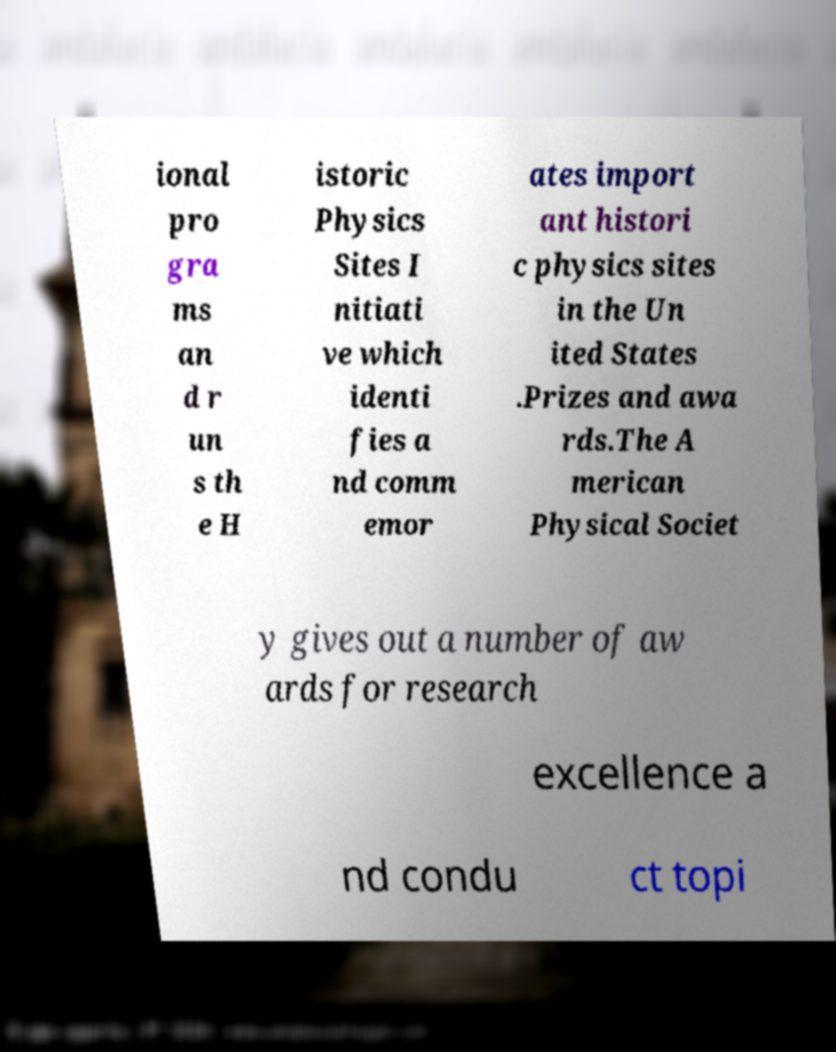Could you extract and type out the text from this image? ional pro gra ms an d r un s th e H istoric Physics Sites I nitiati ve which identi fies a nd comm emor ates import ant histori c physics sites in the Un ited States .Prizes and awa rds.The A merican Physical Societ y gives out a number of aw ards for research excellence a nd condu ct topi 